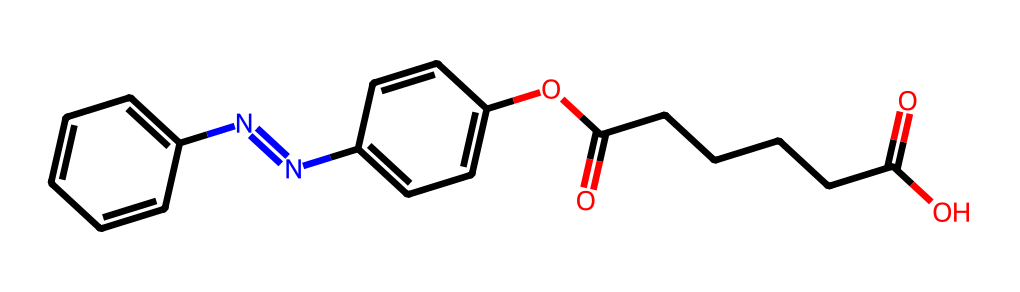What is the molecular formula of the azobenzene derivative represented here? To find the molecular formula, we analyze the structure depicted in the SMILES. We count each type of atom present. The two benzene rings contribute C6H4 each due to the two nitrogen links (N=N). There are also additional carbon and oxygen atoms from the ester and carboxylic acid groups. Counting all atoms gives us C16H18N2O4.
Answer: C16H18N2O4 How many nitrogen atoms are in this chemical structure? The SMILES indicates one instance of 'N=N', which denotes the presence of two nitrogen atoms within the azobenzene system. Thus, we can count two nitrogen atoms directly from this representation.
Answer: 2 What type of functional groups are present in this azobenzene derivative? By examining the structure, we can identify that there are an ester group (OC(=O)) and a carboxylic acid group (C(=O)O) present in addition to the azo group (N=N). Each group is characteristic and defines how it can interact with light.
Answer: ester and carboxylic acid What is the role of the azo group in this chemical? The azo group (N=N) is known for its photoreactive properties. It can undergo cis-trans isomerization upon exposure to UV or visible light. This capability makes it particularly useful in applications like smart windows which can change their electronic and optical properties in response to light stimuli.
Answer: photoreactive What can the presence of an aromatic ring indicate about the stability of this compound? Aromatic rings, such as those present in benzene derivatives, are known for their stability due to resonance. The delocalized electrons across the ring structure provide significant stability compared to aliphatic compounds. Thus, the presence of two aromatic rings in this azobenzene derivative enhances its overall stability.
Answer: stability What is the significance of the carbonyl groups in the context of light-responsive smart windows? The carbonyl groups (C=O) in this azobenzene derivative can affect the electronic properties of the molecule. In the context of smart windows, these groups may play a crucial role in interring with light absorption and enhancing the change in material properties as they respond to light, thereby optimizing its functionality.
Answer: light absorption 